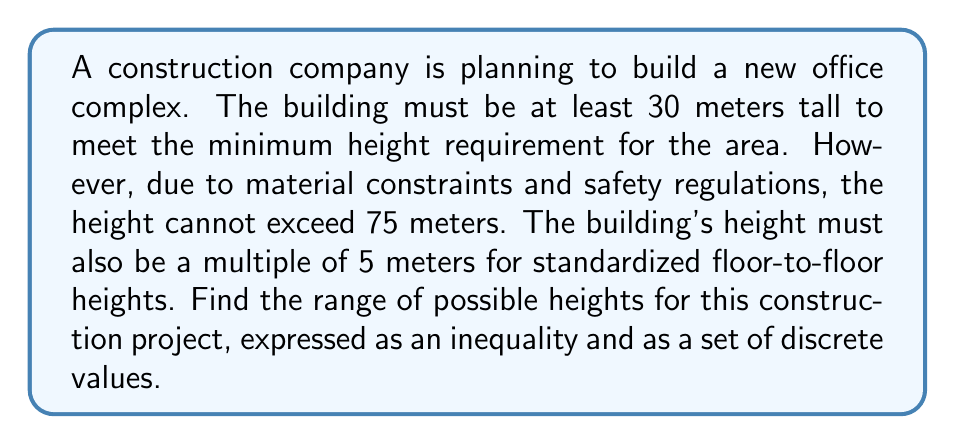Provide a solution to this math problem. Let's approach this step-by-step:

1) First, we need to set up our inequality based on the given information:
   $$ 30 \leq h \leq 75 $$
   where $h$ represents the height of the building in meters.

2) We also know that $h$ must be a multiple of 5. We can express this mathematically as:
   $$ h = 5n $$
   where $n$ is a positive integer.

3) Now, let's find the possible values of $n$:
   $$ 30 \leq 5n \leq 75 $$
   
   Dividing all parts by 5:
   $$ 6 \leq n \leq 15 $$

4) Since $n$ must be an integer, the smallest value it can take is 6, and the largest is 15.

5) Therefore, the possible values for $n$ are: 6, 7, 8, 9, 10, 11, 12, 13, 14, and 15.

6) To get the possible heights, we multiply each of these values by 5:
   $$ h = 5n = \{30, 35, 40, 45, 50, 55, 60, 65, 70, 75\} $$

Thus, the range of possible heights can be expressed as an inequality:
$$ 30 \leq h \leq 75, \text{ where } h \text{ is a multiple of 5} $$

And as a set of discrete values:
$$ h = \{30, 35, 40, 45, 50, 55, 60, 65, 70, 75\} $$
Answer: The range of possible heights:
Inequality: $30 \leq h \leq 75$, where $h$ is a multiple of 5
Discrete values: $h = \{30, 35, 40, 45, 50, 55, 60, 65, 70, 75\}$ 